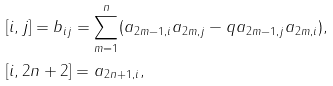Convert formula to latex. <formula><loc_0><loc_0><loc_500><loc_500>& [ i , j ] = b _ { i j } = \sum _ { m = 1 } ^ { n } ( a _ { 2 m - 1 , i } a _ { 2 m , j } - q a _ { 2 m - 1 , j } a _ { 2 m , i } ) , \\ & [ i , 2 n + 2 ] = a _ { 2 n + 1 , i } ,</formula> 